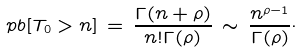Convert formula to latex. <formula><loc_0><loc_0><loc_500><loc_500>\ p b [ T _ { 0 } > n ] \, = \, \frac { \Gamma ( n + \rho ) } { n ! \Gamma ( \rho ) } \, \sim \, \frac { n ^ { \rho - 1 } } { \Gamma ( \rho ) } \cdot</formula> 